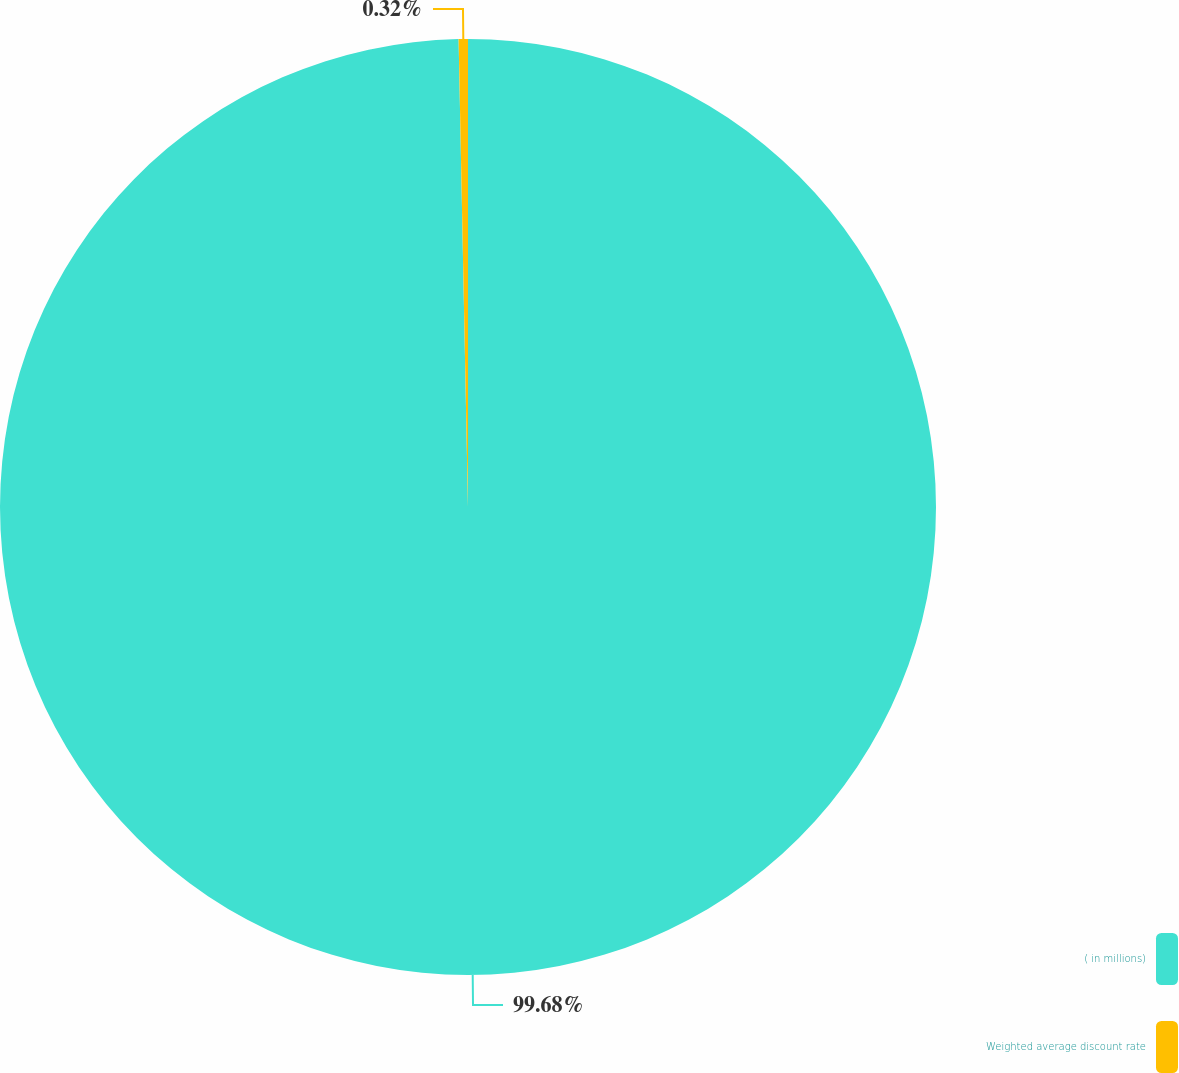Convert chart to OTSL. <chart><loc_0><loc_0><loc_500><loc_500><pie_chart><fcel>( in millions)<fcel>Weighted average discount rate<nl><fcel>99.68%<fcel>0.32%<nl></chart> 